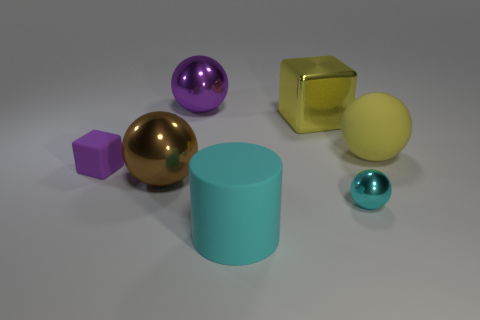There is another yellow thing that is the same shape as the small metal object; what material is it?
Your answer should be compact. Rubber. There is a small thing that is the same color as the large cylinder; what is its shape?
Make the answer very short. Sphere. What number of brown things are the same shape as the cyan metallic thing?
Keep it short and to the point. 1. What is the size of the purple object that is to the right of the large metallic object that is in front of the tiny matte cube?
Provide a succinct answer. Large. How many yellow things are blocks or big rubber spheres?
Your answer should be very brief. 2. Are there fewer tiny cyan metallic spheres that are right of the yellow rubber object than big matte cylinders that are on the right side of the yellow cube?
Give a very brief answer. No. There is a cyan ball; does it have the same size as the cyan object that is in front of the cyan ball?
Your answer should be compact. No. What number of other purple rubber cubes are the same size as the purple cube?
Your answer should be very brief. 0. How many small things are either yellow rubber objects or purple matte cubes?
Make the answer very short. 1. Are any cyan matte cylinders visible?
Your response must be concise. Yes. 